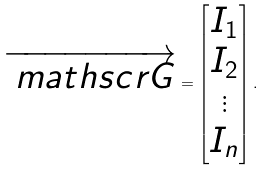<formula> <loc_0><loc_0><loc_500><loc_500>\overrightarrow { \ m a t h s c r { G } } = \left [ \begin{matrix} I _ { 1 } \\ I _ { 2 } \\ \vdots \\ I _ { n } \end{matrix} \right ] .</formula> 